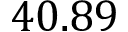Convert formula to latex. <formula><loc_0><loc_0><loc_500><loc_500>4 0 . 8 9</formula> 